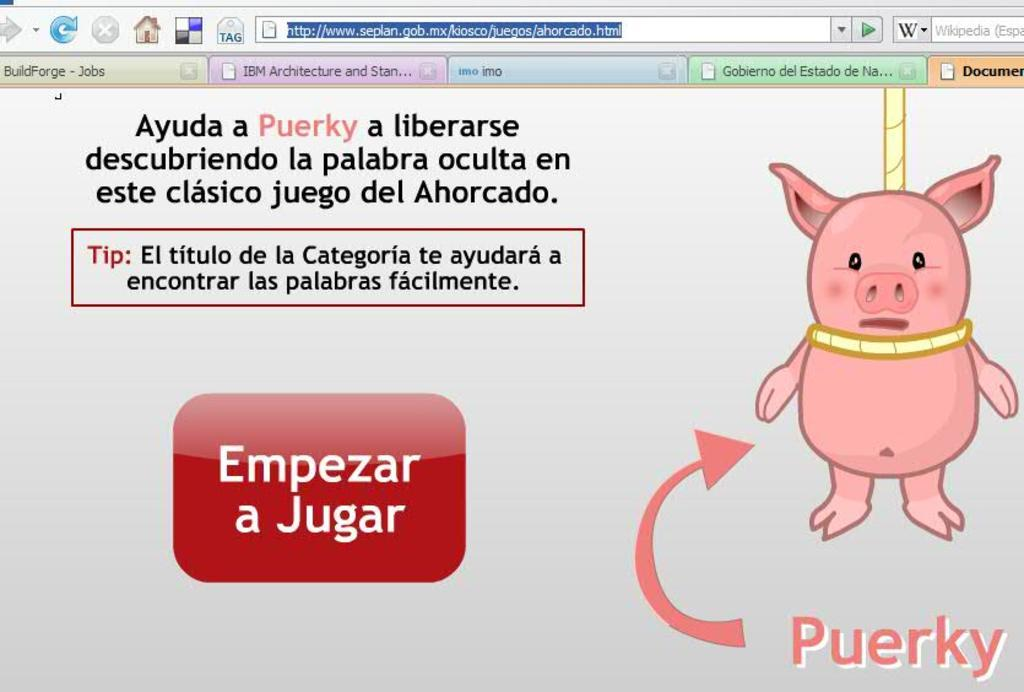What type of content is displayed in the image? The image is a web page. What type of elements can be found on the web page? There are folders, icons, a search bar, and words on the web page. Can you describe a specific object on the web page? There is a cartoon pig hanging with a rope on the web page. What type of iron can be seen on the sidewalk in the image? There is no iron or sidewalk present in the image; it is a web page with various elements, including a cartoon pig hanging with a rope. How many cushions are visible on the web page? There are no cushions present in the image; it is a web page with various elements, including a cartoon pig hanging with a rope. 